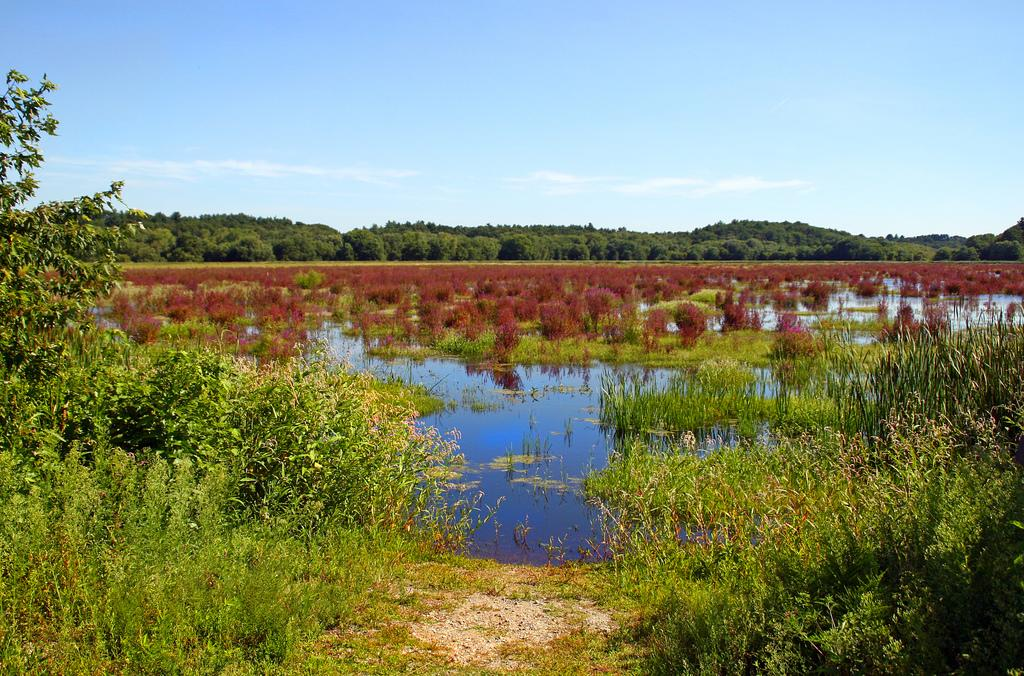What type of vegetation can be seen in the image? There are plants and trees visible in the image. What natural element is present in the image? Water is visible in the image. What part of the natural environment is visible in the image? The sky is visible in the image. What type of bean is growing on the bushes in the image? There are no beans or bushes present in the image; it features plants, trees, water, and the sky. Can you describe the driving conditions in the image? There is no reference to driving or vehicles in the image, so it's not possible to determine the driving conditions. 